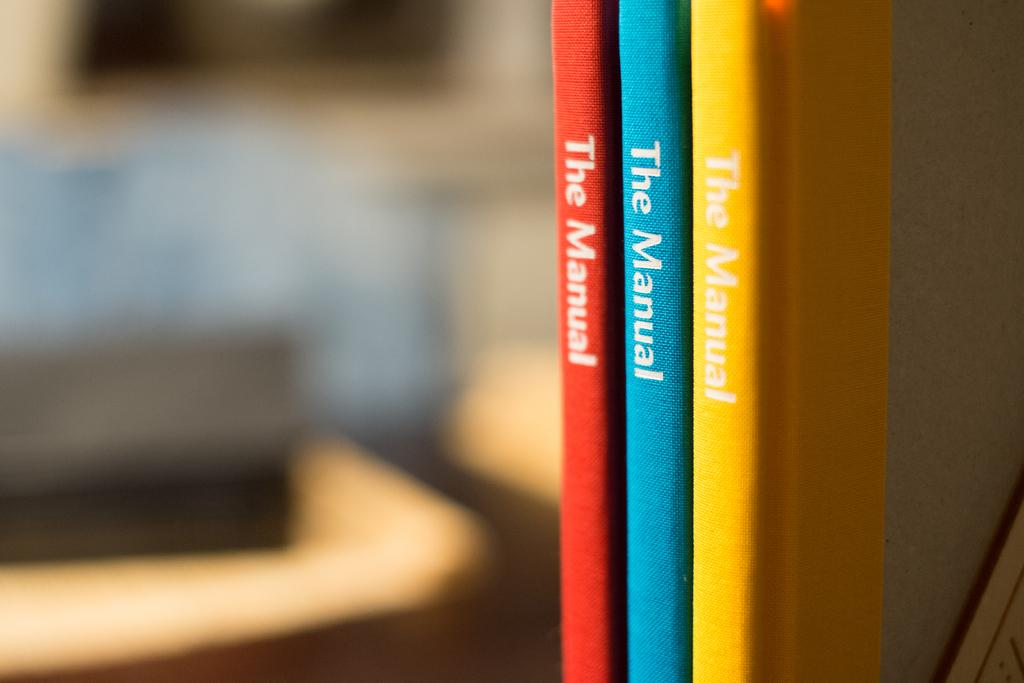<image>
Render a clear and concise summary of the photo. The Manual books are shown in three different colors 